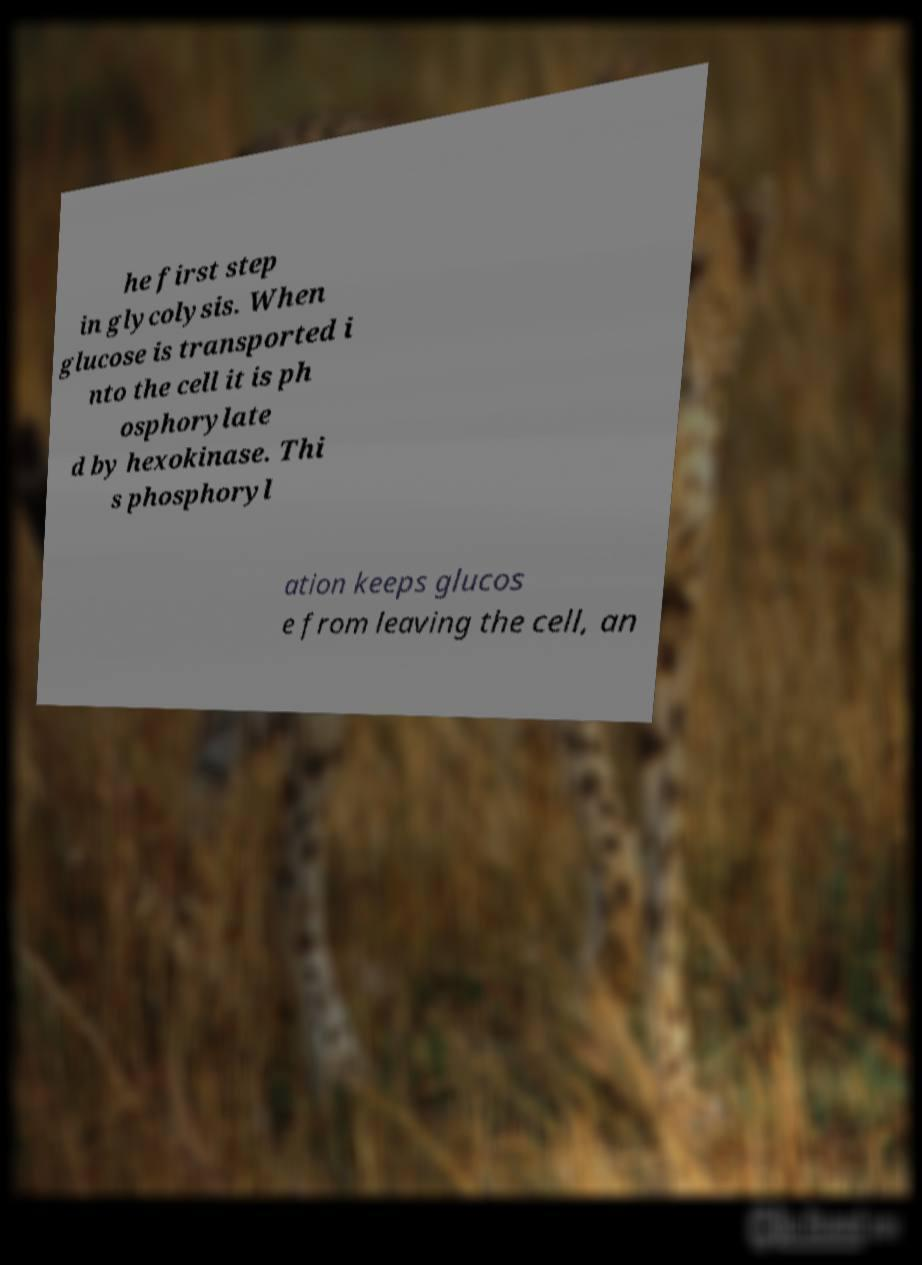For documentation purposes, I need the text within this image transcribed. Could you provide that? he first step in glycolysis. When glucose is transported i nto the cell it is ph osphorylate d by hexokinase. Thi s phosphoryl ation keeps glucos e from leaving the cell, an 